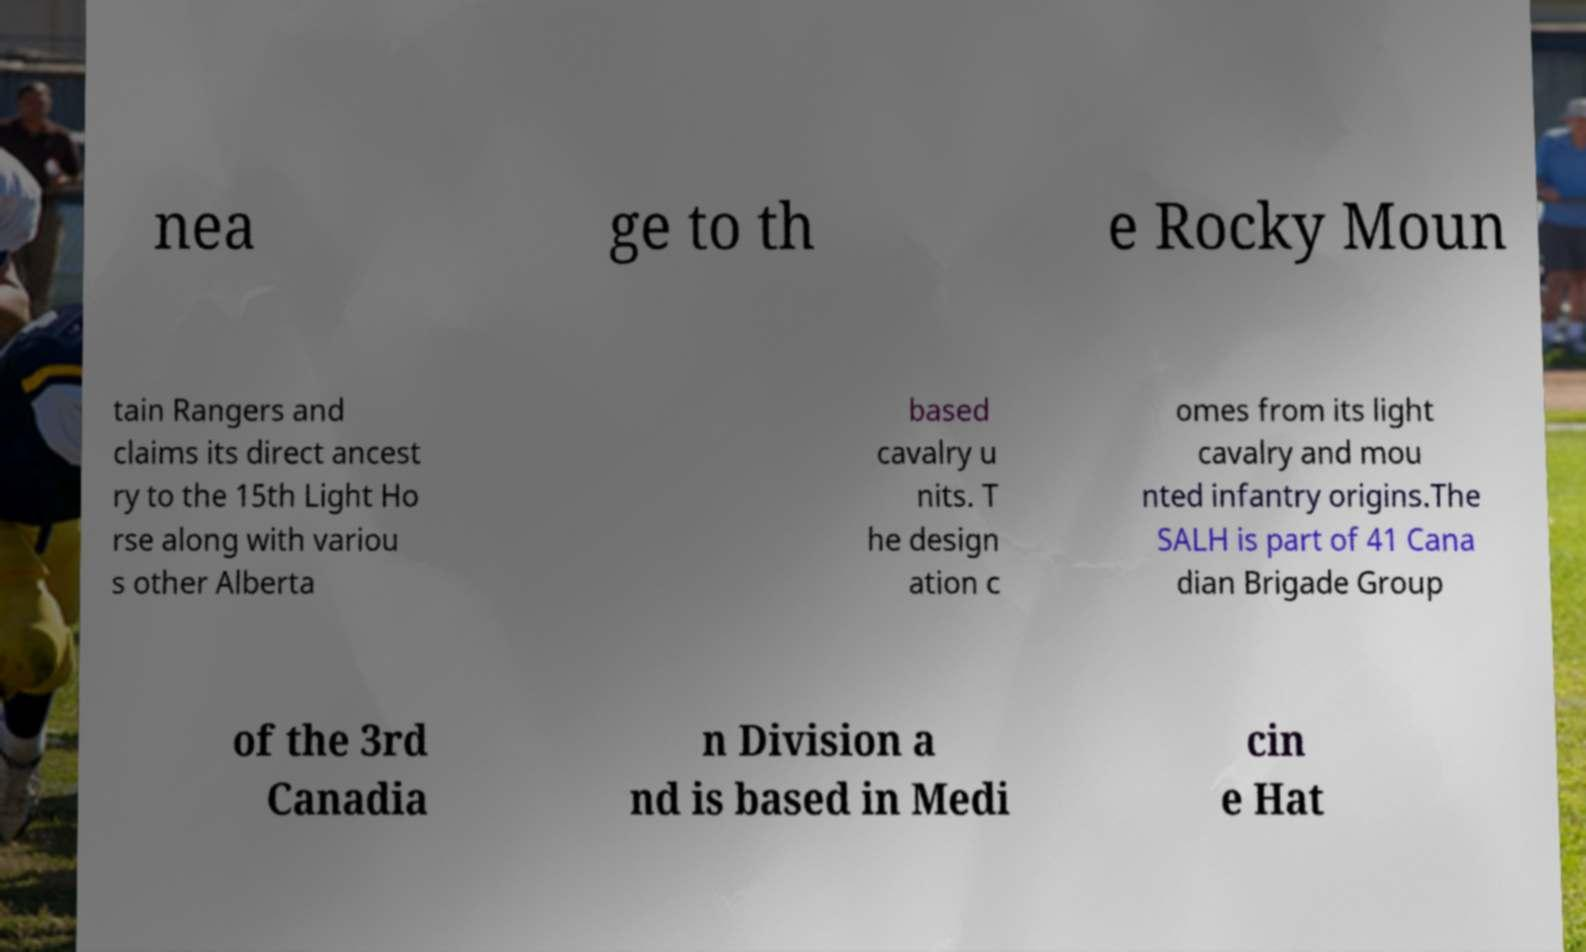Please identify and transcribe the text found in this image. nea ge to th e Rocky Moun tain Rangers and claims its direct ancest ry to the 15th Light Ho rse along with variou s other Alberta based cavalry u nits. T he design ation c omes from its light cavalry and mou nted infantry origins.The SALH is part of 41 Cana dian Brigade Group of the 3rd Canadia n Division a nd is based in Medi cin e Hat 